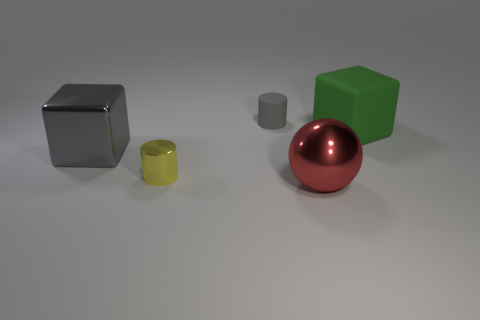Add 2 large cubes. How many objects exist? 7 Subtract all gray cubes. How many cubes are left? 1 Subtract 2 cylinders. How many cylinders are left? 0 Add 1 gray objects. How many gray objects exist? 3 Subtract 0 yellow balls. How many objects are left? 5 Subtract all balls. How many objects are left? 4 Subtract all brown cylinders. Subtract all green cubes. How many cylinders are left? 2 Subtract all gray cylinders. How many gray cubes are left? 1 Subtract all cylinders. Subtract all big green objects. How many objects are left? 2 Add 3 rubber cylinders. How many rubber cylinders are left? 4 